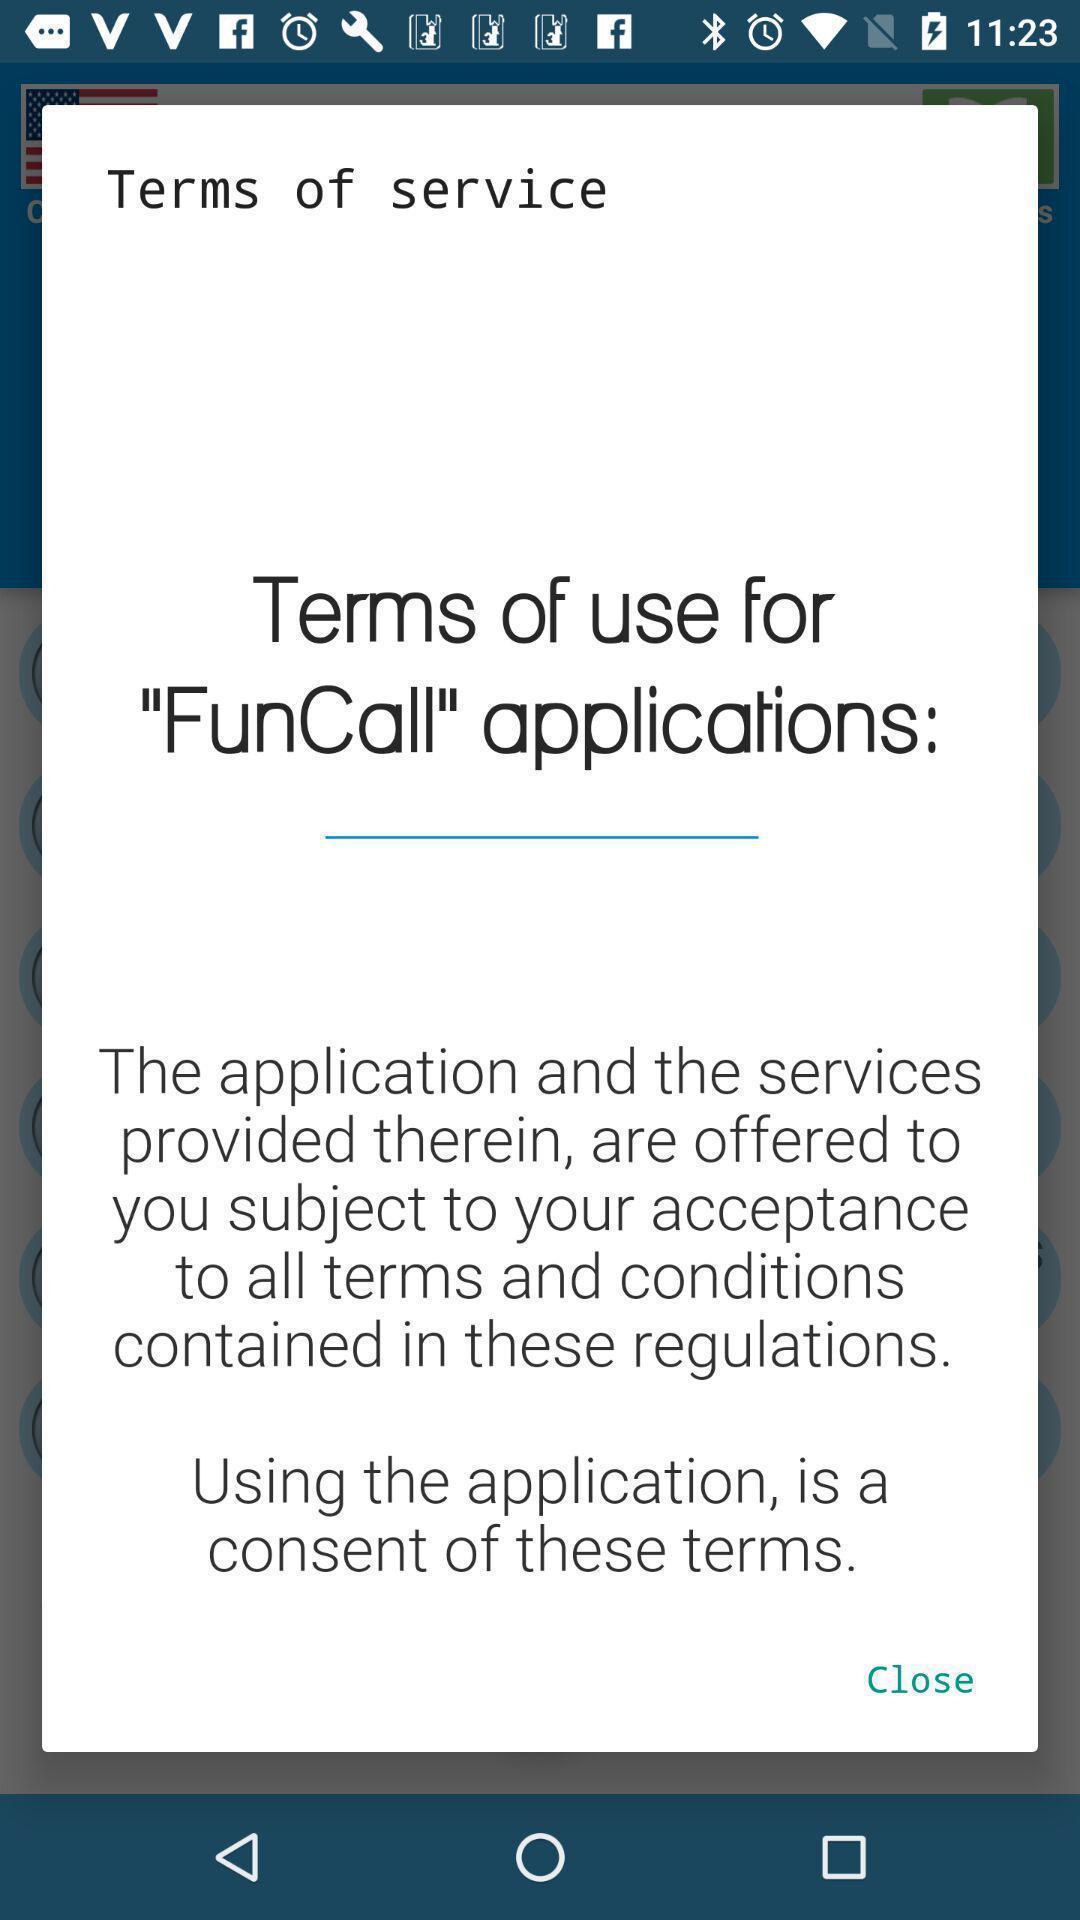Give me a narrative description of this picture. Terms of services page in a social app. 